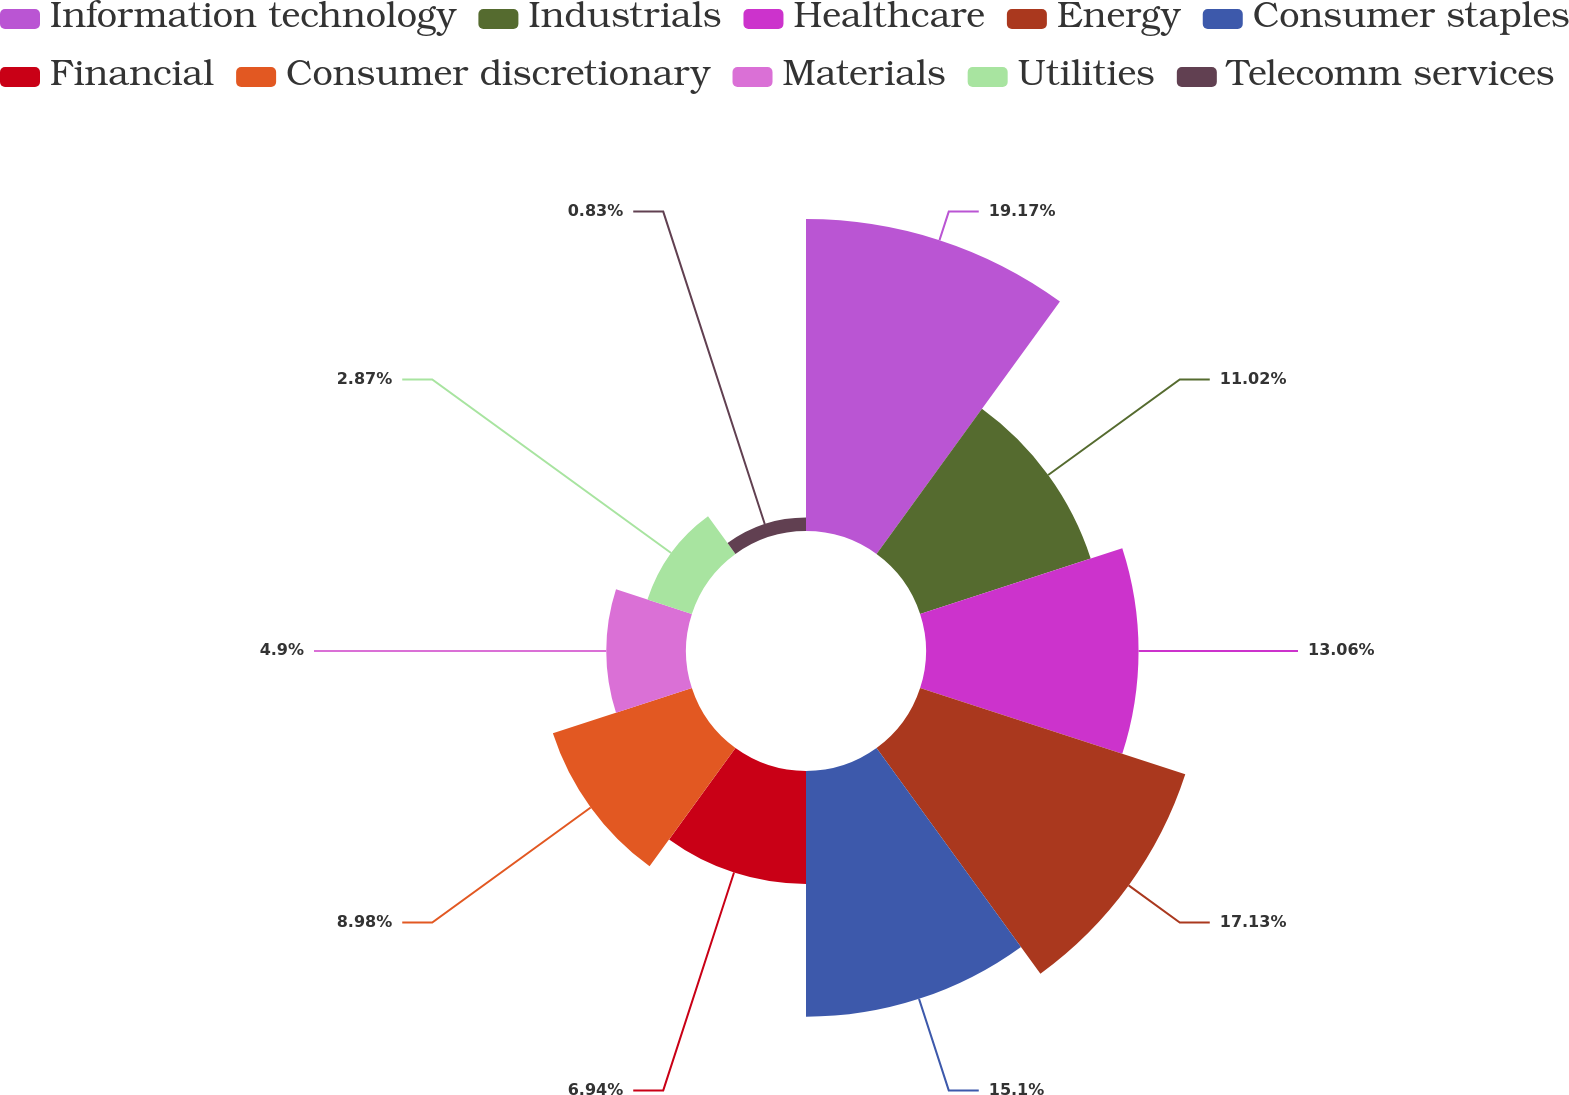Convert chart to OTSL. <chart><loc_0><loc_0><loc_500><loc_500><pie_chart><fcel>Information technology<fcel>Industrials<fcel>Healthcare<fcel>Energy<fcel>Consumer staples<fcel>Financial<fcel>Consumer discretionary<fcel>Materials<fcel>Utilities<fcel>Telecomm services<nl><fcel>19.17%<fcel>11.02%<fcel>13.06%<fcel>17.13%<fcel>15.1%<fcel>6.94%<fcel>8.98%<fcel>4.9%<fcel>2.87%<fcel>0.83%<nl></chart> 